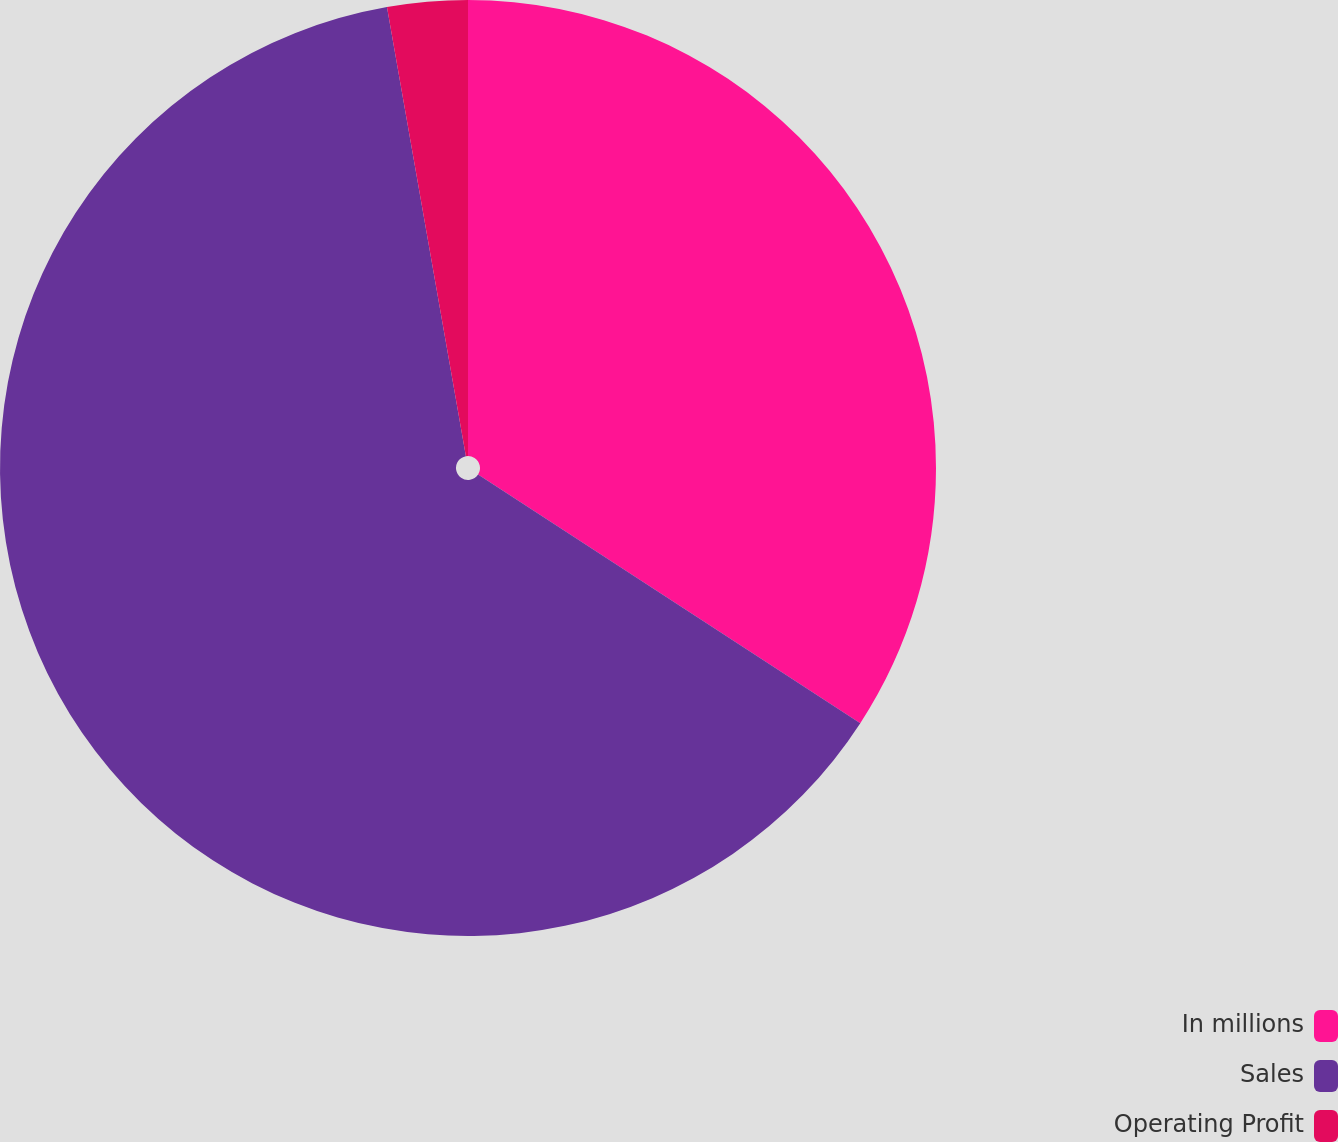<chart> <loc_0><loc_0><loc_500><loc_500><pie_chart><fcel>In millions<fcel>Sales<fcel>Operating Profit<nl><fcel>34.18%<fcel>63.05%<fcel>2.77%<nl></chart> 